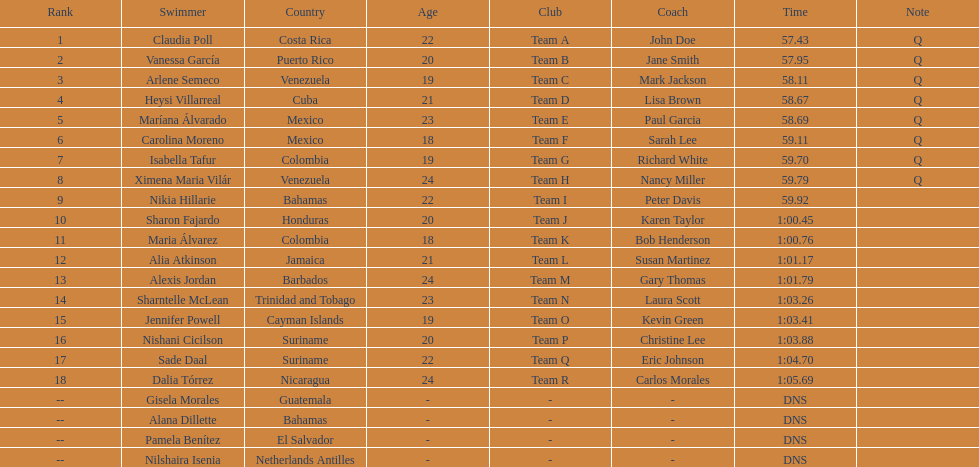How many competitors did not start the preliminaries? 4. 